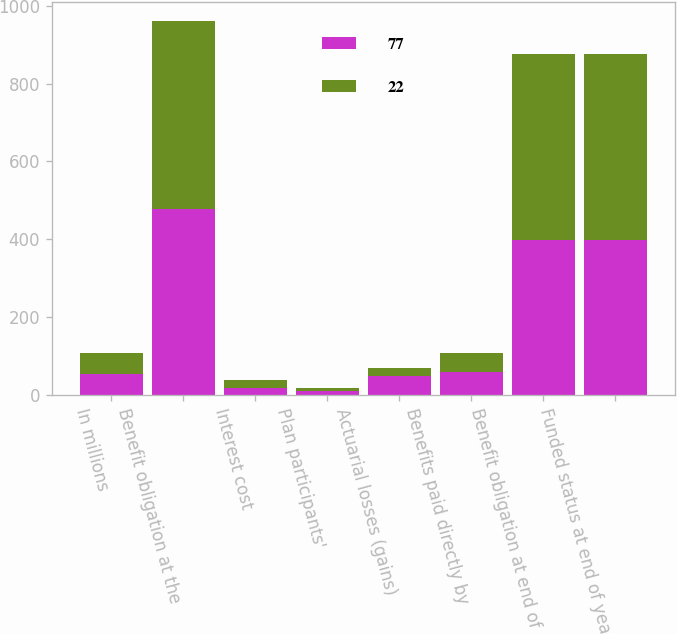Convert chart. <chart><loc_0><loc_0><loc_500><loc_500><stacked_bar_chart><ecel><fcel>In millions<fcel>Benefit obligation at the<fcel>Interest cost<fcel>Plan participants'<fcel>Actuarial losses (gains)<fcel>Benefits paid directly by<fcel>Benefit obligation at end of<fcel>Funded status at end of year<nl><fcel>77<fcel>54.5<fcel>478<fcel>17<fcel>10<fcel>49<fcel>58<fcel>398<fcel>398<nl><fcel>22<fcel>54.5<fcel>483<fcel>21<fcel>8<fcel>21<fcel>51<fcel>478<fcel>478<nl></chart> 